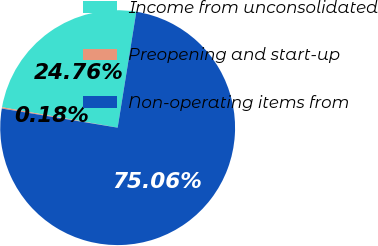Convert chart. <chart><loc_0><loc_0><loc_500><loc_500><pie_chart><fcel>Income from unconsolidated<fcel>Preopening and start-up<fcel>Non-operating items from<nl><fcel>24.76%<fcel>0.18%<fcel>75.06%<nl></chart> 